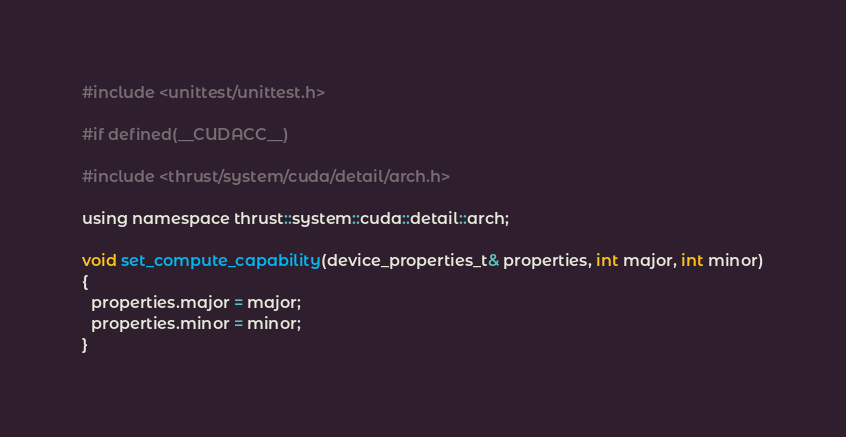Convert code to text. <code><loc_0><loc_0><loc_500><loc_500><_Cuda_>#include <unittest/unittest.h>

#if defined(__CUDACC__)

#include <thrust/system/cuda/detail/arch.h>

using namespace thrust::system::cuda::detail::arch;

void set_compute_capability(device_properties_t& properties, int major, int minor)
{
  properties.major = major;
  properties.minor = minor;
}
</code> 